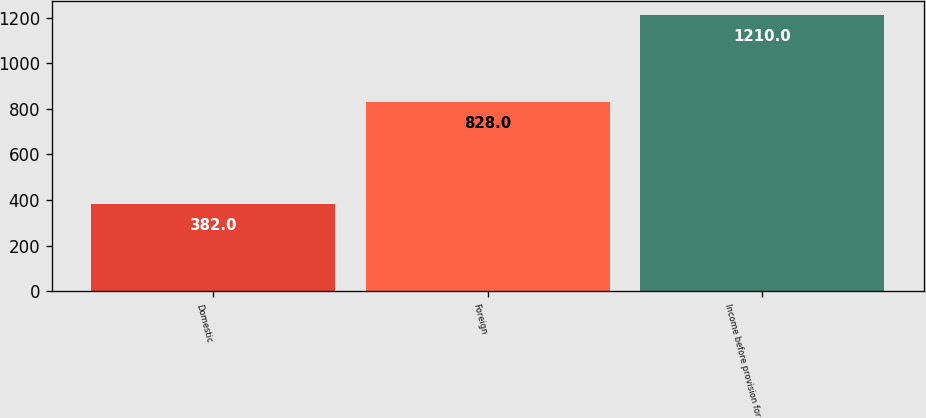<chart> <loc_0><loc_0><loc_500><loc_500><bar_chart><fcel>Domestic<fcel>Foreign<fcel>Income before provision for<nl><fcel>382<fcel>828<fcel>1210<nl></chart> 